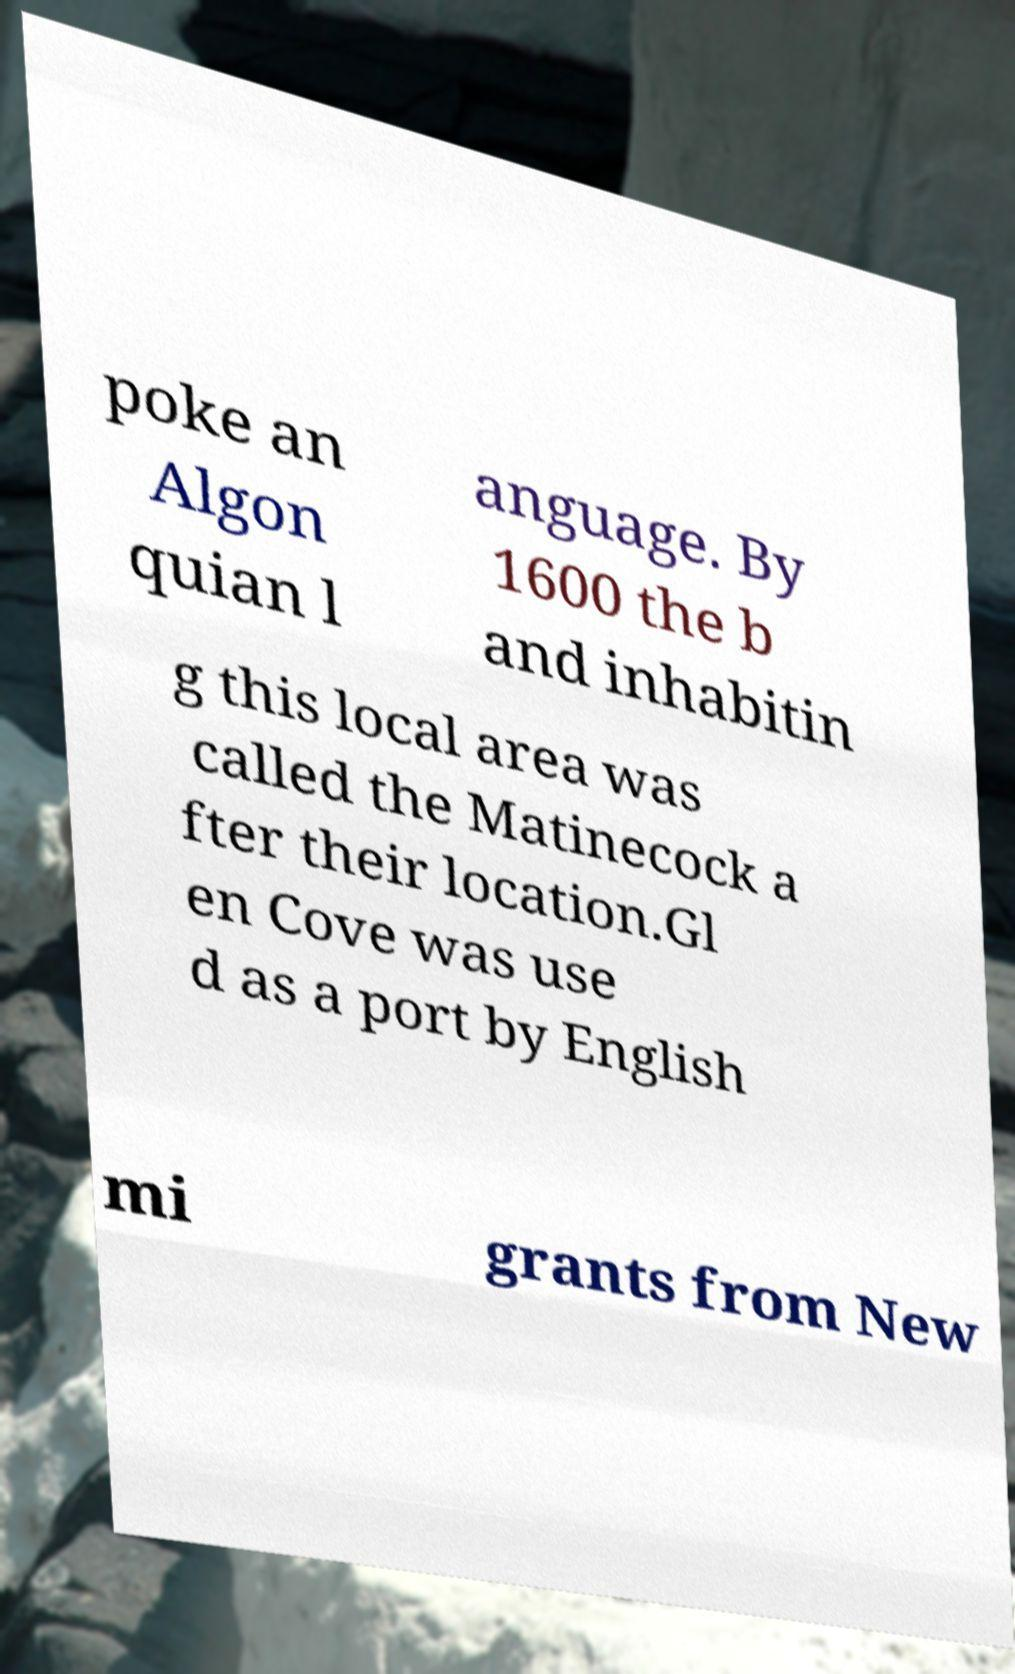I need the written content from this picture converted into text. Can you do that? poke an Algon quian l anguage. By 1600 the b and inhabitin g this local area was called the Matinecock a fter their location.Gl en Cove was use d as a port by English mi grants from New 